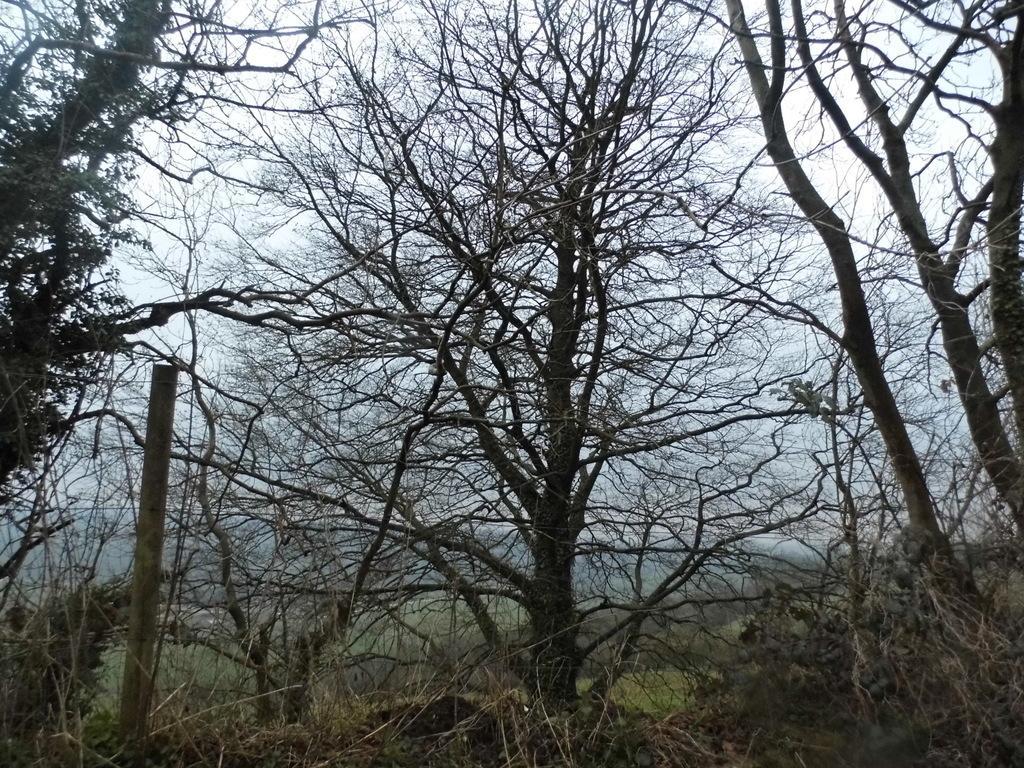In one or two sentences, can you explain what this image depicts? In this image we can see some trees and a pole, in the back ground we can see the sky. 